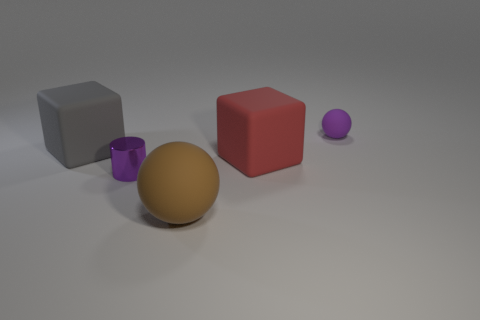How many cyan objects are either tiny rubber cylinders or large matte things?
Your answer should be very brief. 0. How many other objects are the same material as the brown object?
Provide a short and direct response. 3. There is a small thing that is behind the large gray cube; is its shape the same as the big gray rubber thing?
Your answer should be compact. No. Are there any big blocks?
Give a very brief answer. Yes. Is there any other thing that has the same shape as the large gray thing?
Ensure brevity in your answer.  Yes. Are there more big red matte objects in front of the red object than purple metal cylinders?
Provide a succinct answer. No. There is a purple shiny cylinder; are there any small purple cylinders behind it?
Give a very brief answer. No. Do the purple cylinder and the purple rubber object have the same size?
Your answer should be compact. Yes. The red object that is the same shape as the gray object is what size?
Keep it short and to the point. Large. What material is the sphere behind the big block on the left side of the small metallic object?
Give a very brief answer. Rubber. 